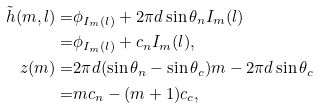<formula> <loc_0><loc_0><loc_500><loc_500>\tilde { h } ( m , l ) = & \phi _ { I _ { m } ( l ) } + 2 \pi d \sin { \theta _ { n } } I _ { m } ( l ) \\ = & \phi _ { I _ { m } ( l ) } + c _ { n } I _ { m } ( l ) , \\ z ( m ) = & 2 \pi d ( \sin { \theta _ { n } } - \sin { \theta _ { c } } ) m - 2 \pi d \sin { \theta _ { c } } \\ = & m c _ { n } - ( m + 1 ) c _ { c } ,</formula> 